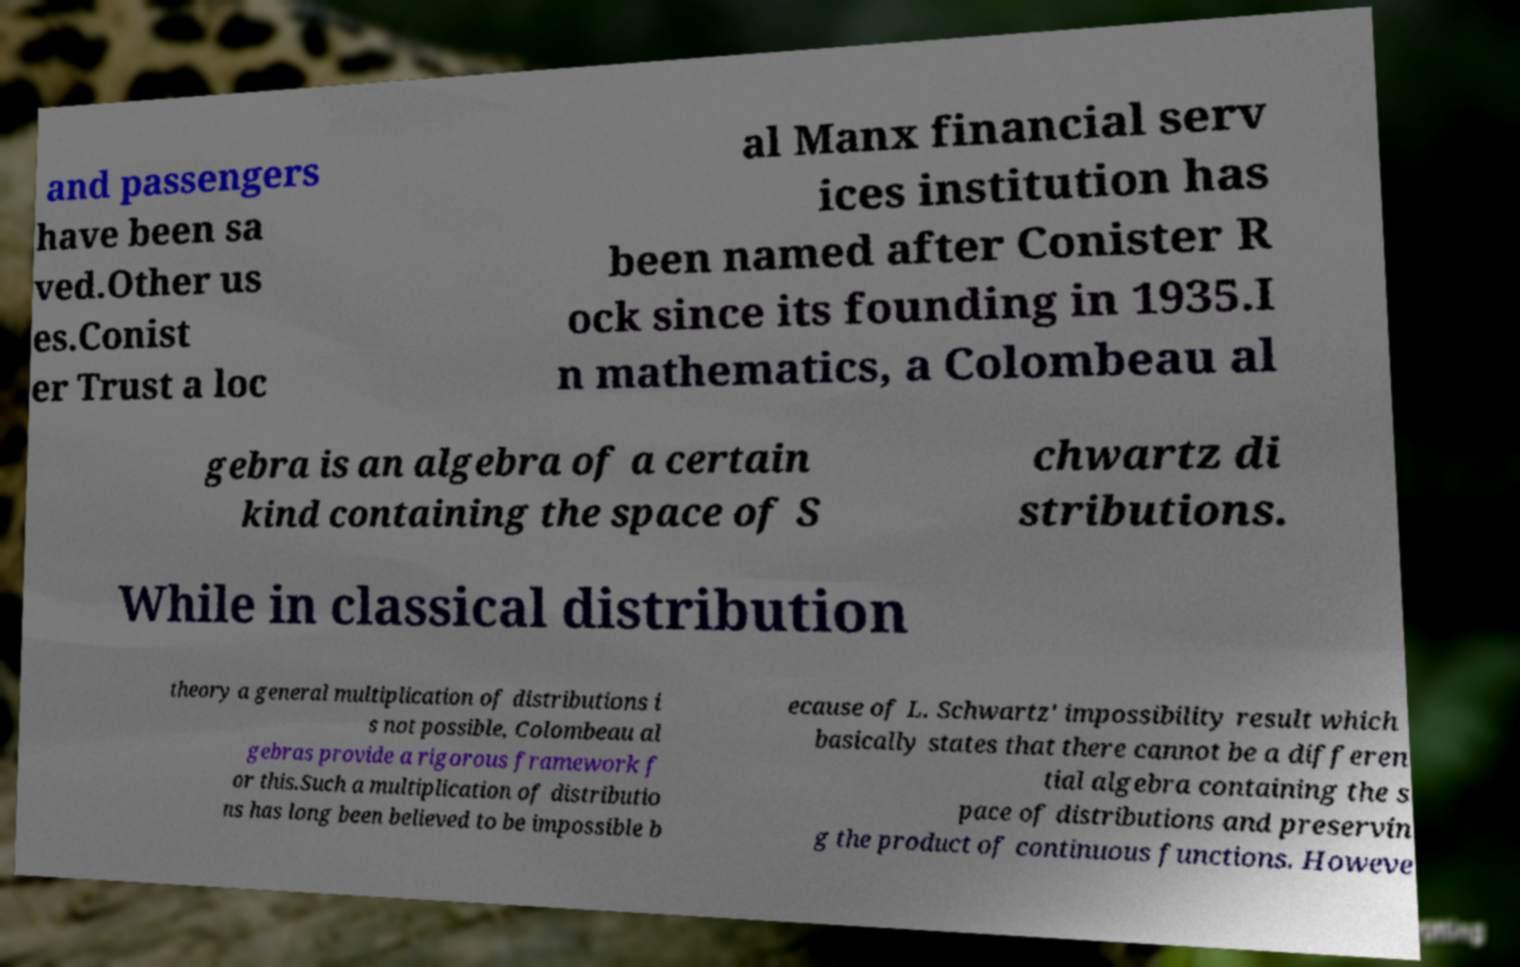I need the written content from this picture converted into text. Can you do that? and passengers have been sa ved.Other us es.Conist er Trust a loc al Manx financial serv ices institution has been named after Conister R ock since its founding in 1935.I n mathematics, a Colombeau al gebra is an algebra of a certain kind containing the space of S chwartz di stributions. While in classical distribution theory a general multiplication of distributions i s not possible, Colombeau al gebras provide a rigorous framework f or this.Such a multiplication of distributio ns has long been believed to be impossible b ecause of L. Schwartz' impossibility result which basically states that there cannot be a differen tial algebra containing the s pace of distributions and preservin g the product of continuous functions. Howeve 